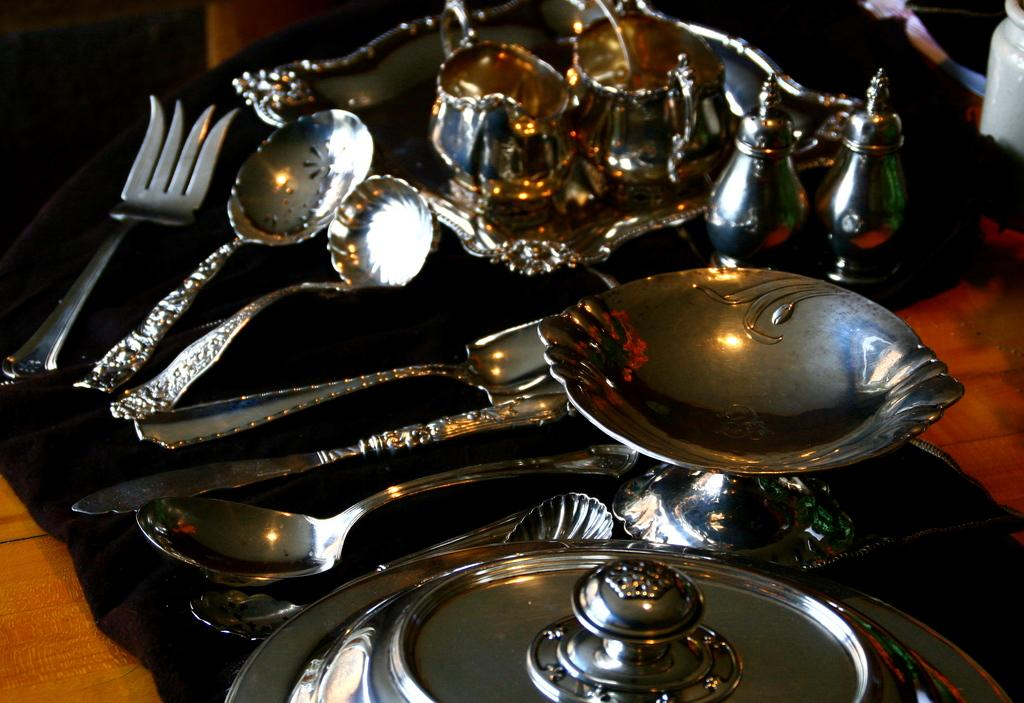What is the main object in the image? There is a tray in the image. What items are placed on the tray? There are cups, spoons, a fork, a plate, and a sauce boat placed on the tray. What is the color of the cloth that the tray is placed on? The black cloth is placed on a table. What type of utensils can be seen in the image? There are spoons and a fork visible in the image. How many birds are sitting on the cap in the image? There is no cap or birds present in the image. Which direction is north in the image? The concept of north is not relevant to the image, as it does not contain any geographical or directional elements. 